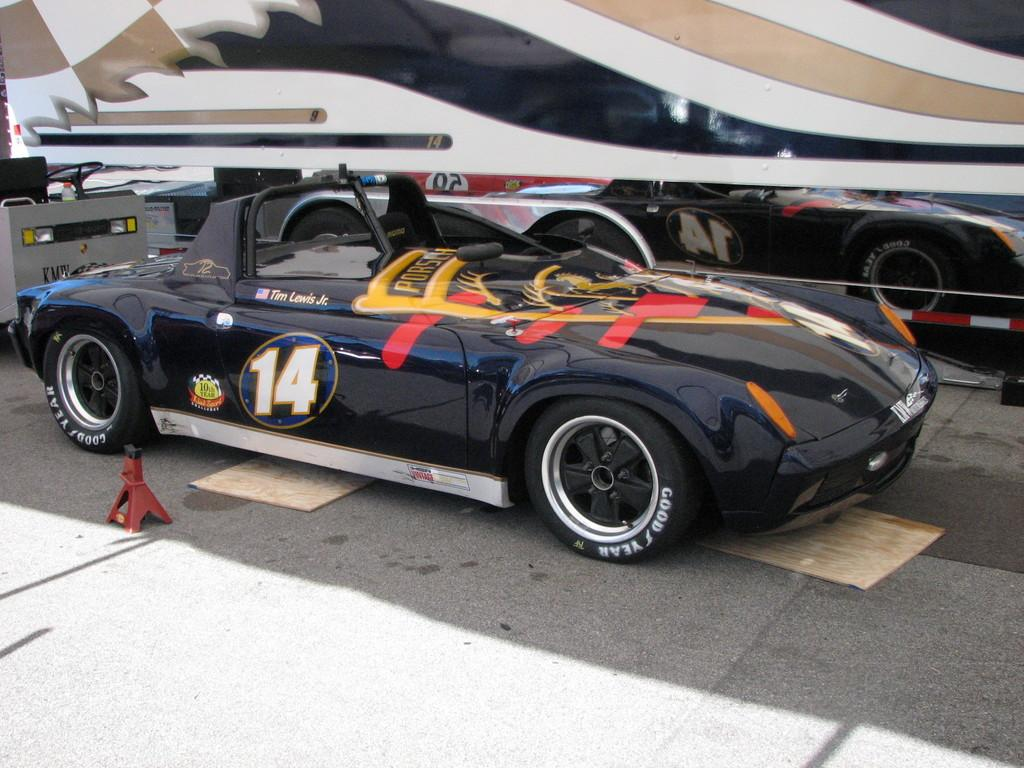Provide a one-sentence caption for the provided image. A black racing car with the number 14 on its door. 